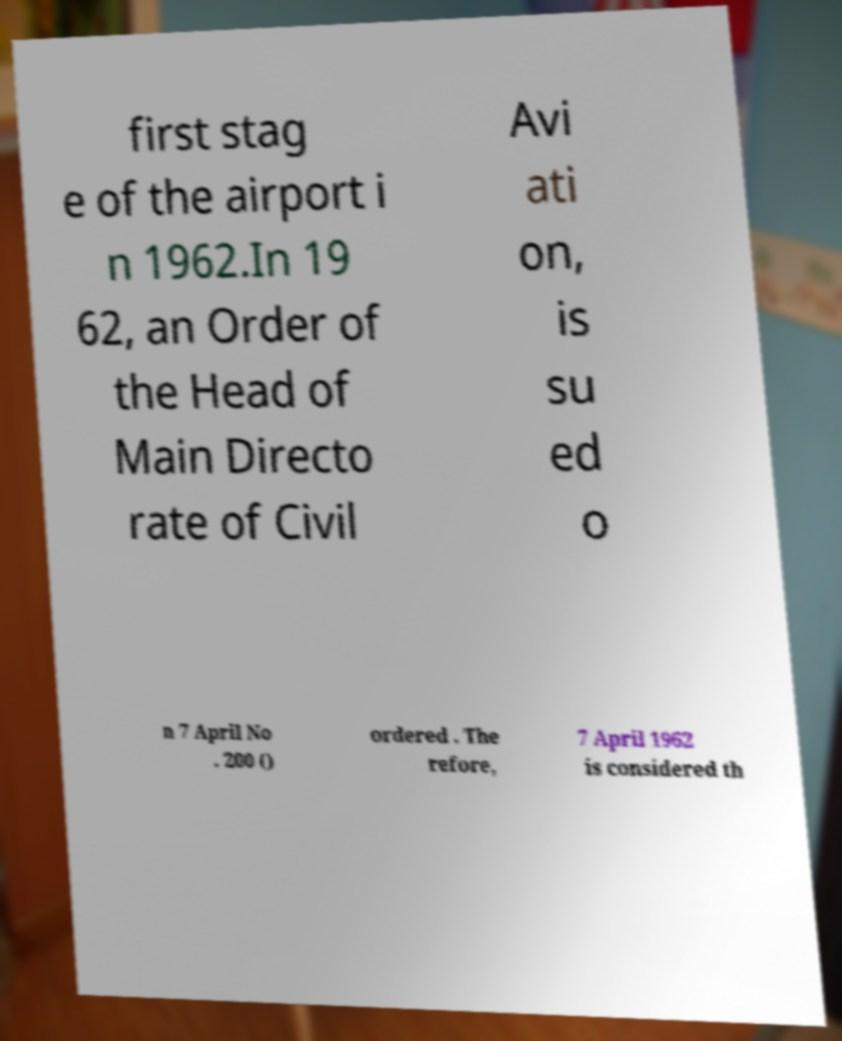What messages or text are displayed in this image? I need them in a readable, typed format. first stag e of the airport i n 1962.In 19 62, an Order of the Head of Main Directo rate of Civil Avi ati on, is su ed o n 7 April No . 200 () ordered . The refore, 7 April 1962 is considered th 